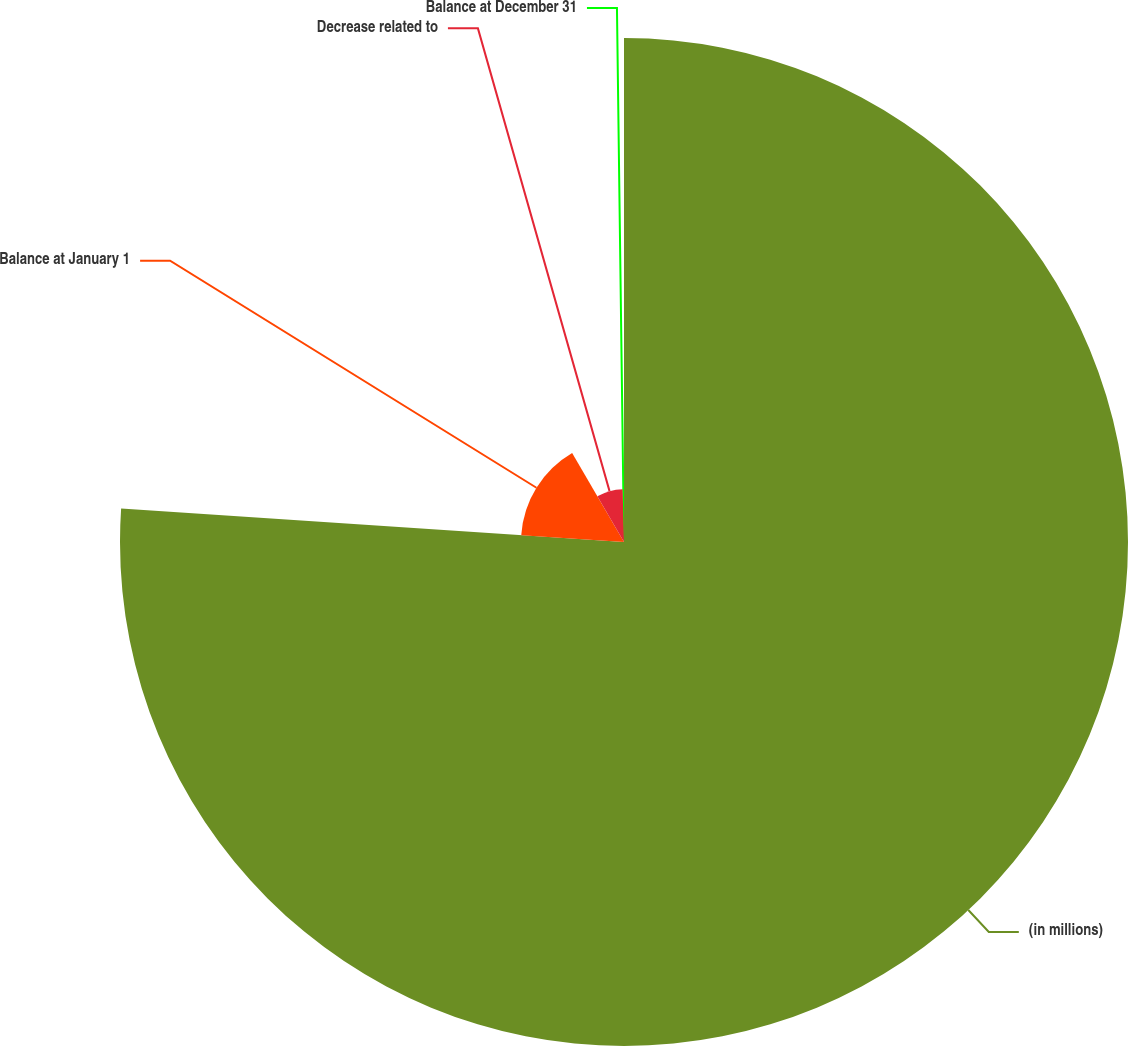Convert chart to OTSL. <chart><loc_0><loc_0><loc_500><loc_500><pie_chart><fcel>(in millions)<fcel>Balance at January 1<fcel>Decrease related to<fcel>Balance at December 31<nl><fcel>76.06%<fcel>15.54%<fcel>7.98%<fcel>0.42%<nl></chart> 